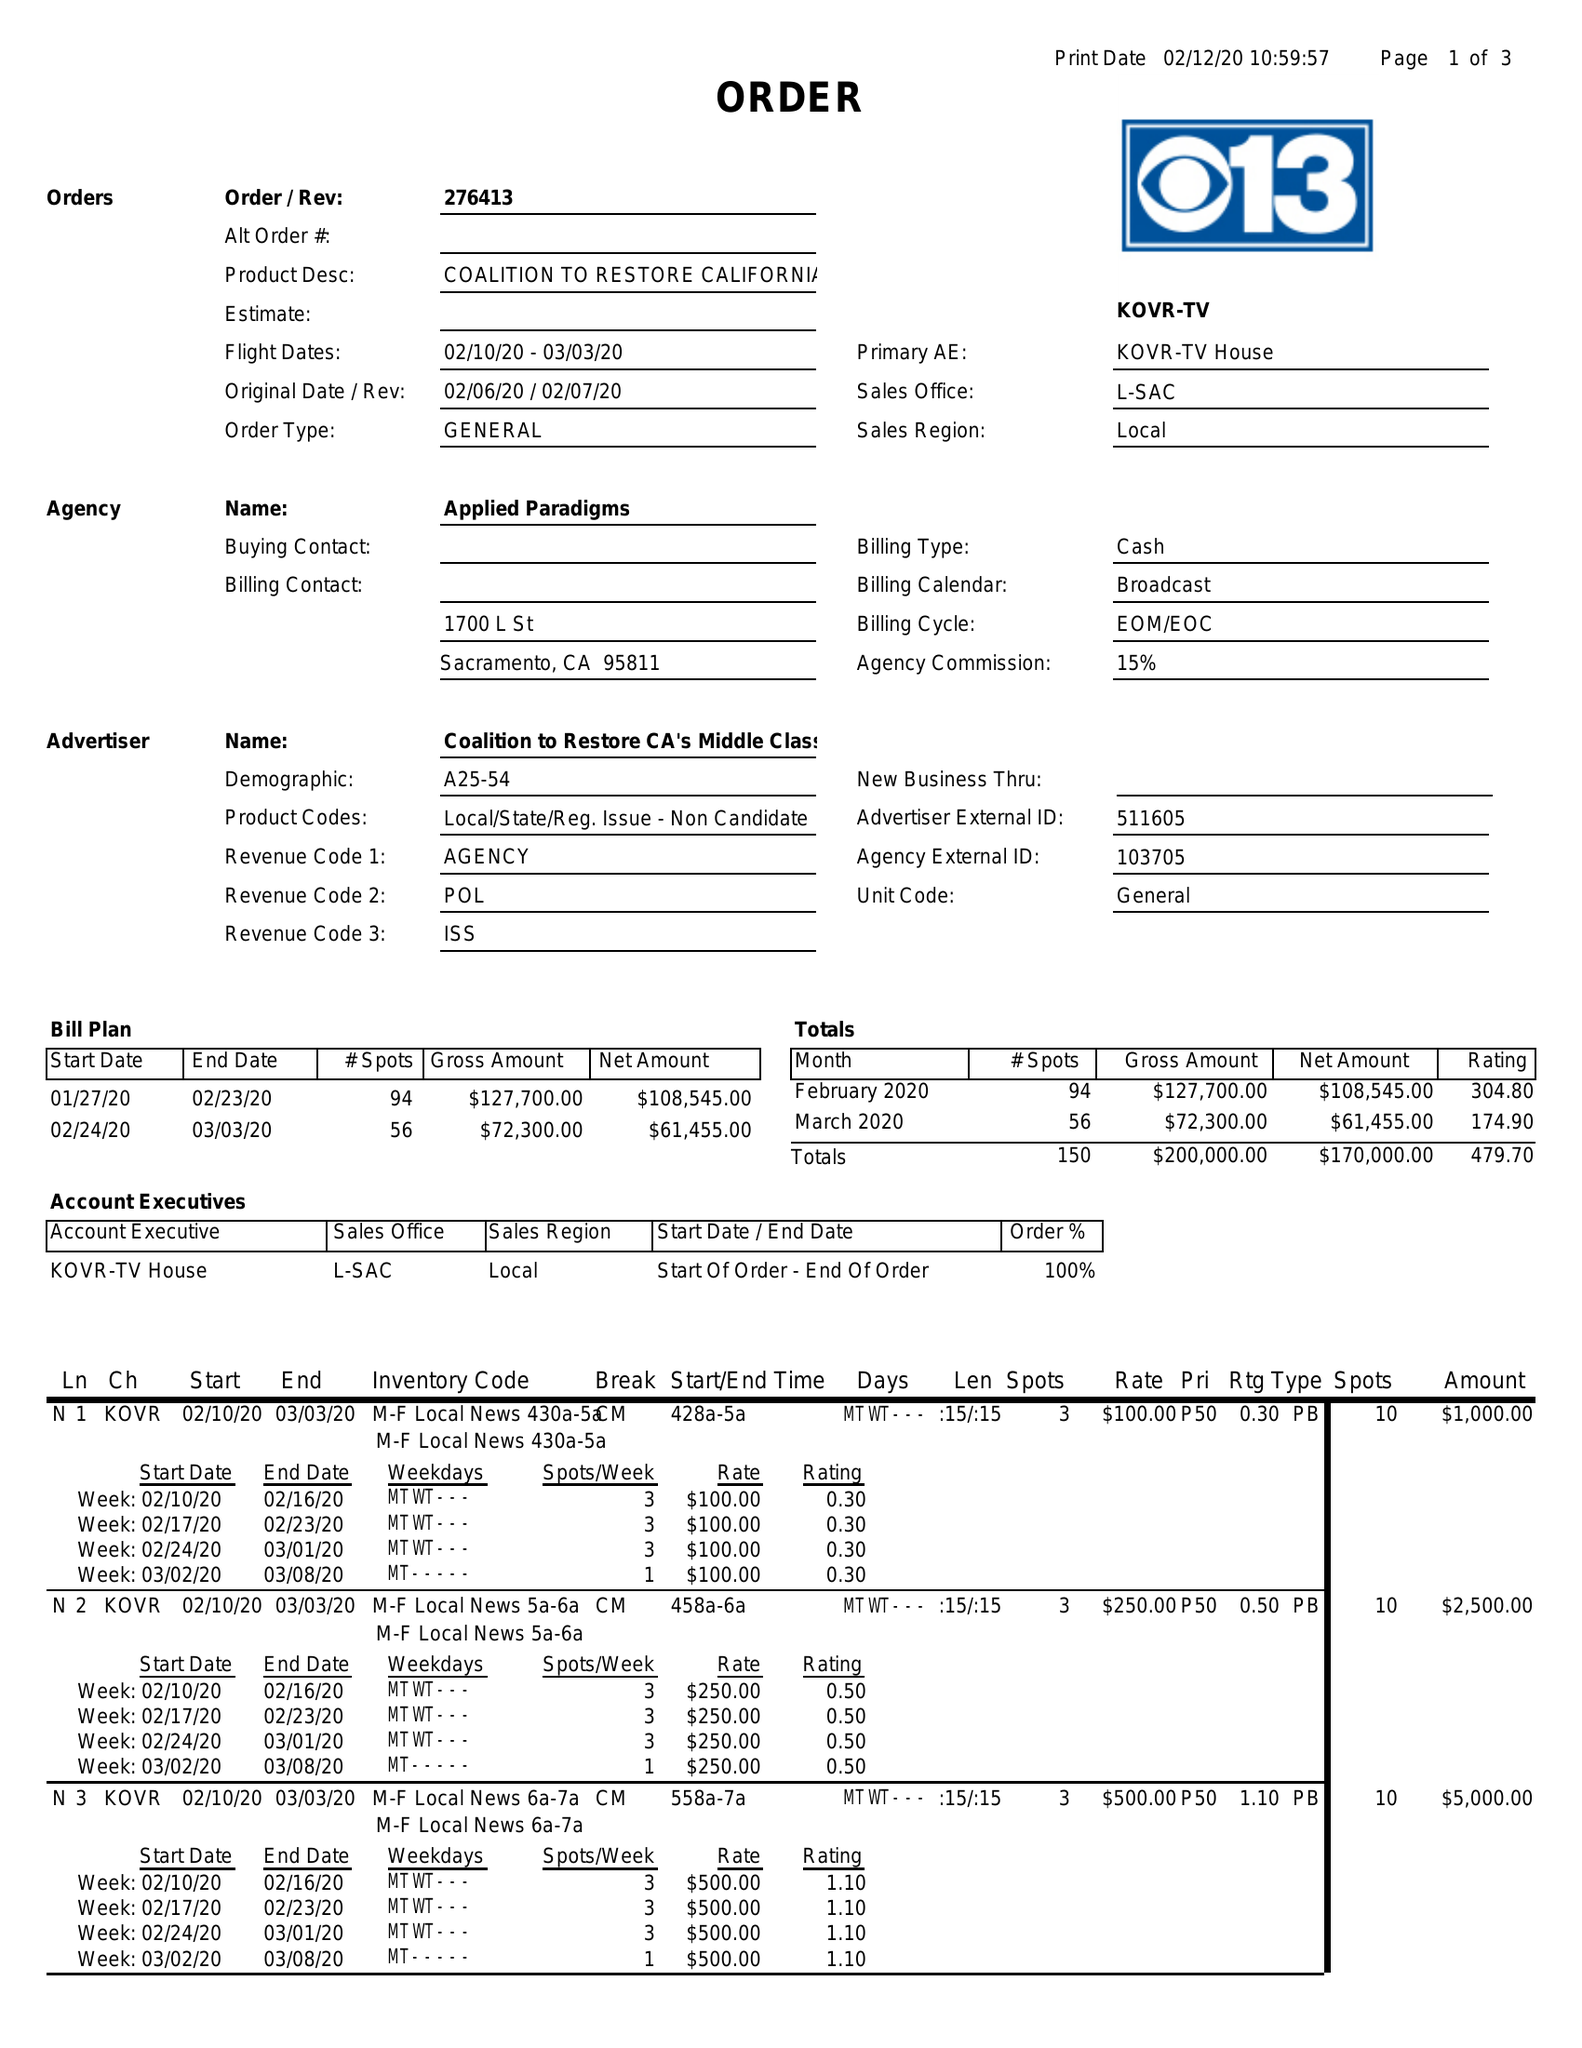What is the value for the flight_to?
Answer the question using a single word or phrase. 03/03/20 